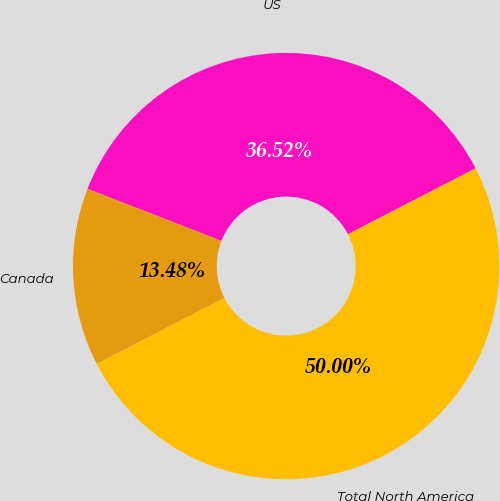<chart> <loc_0><loc_0><loc_500><loc_500><pie_chart><fcel>US<fcel>Canada<fcel>Total North America<nl><fcel>36.52%<fcel>13.48%<fcel>50.0%<nl></chart> 